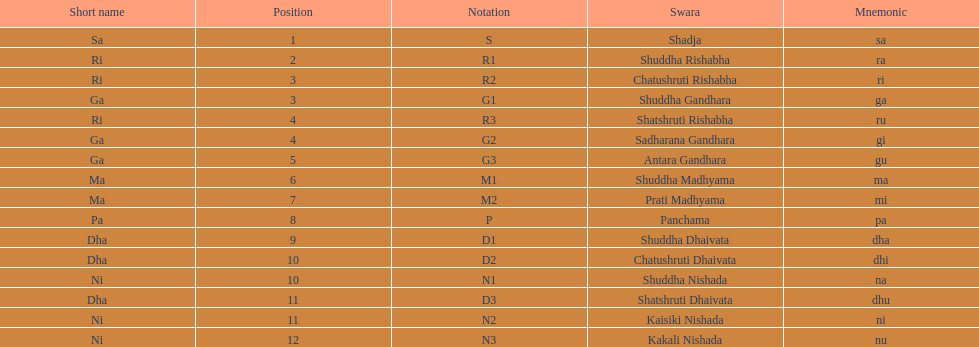On average how many of the swara have a short name that begin with d or g? 6. 